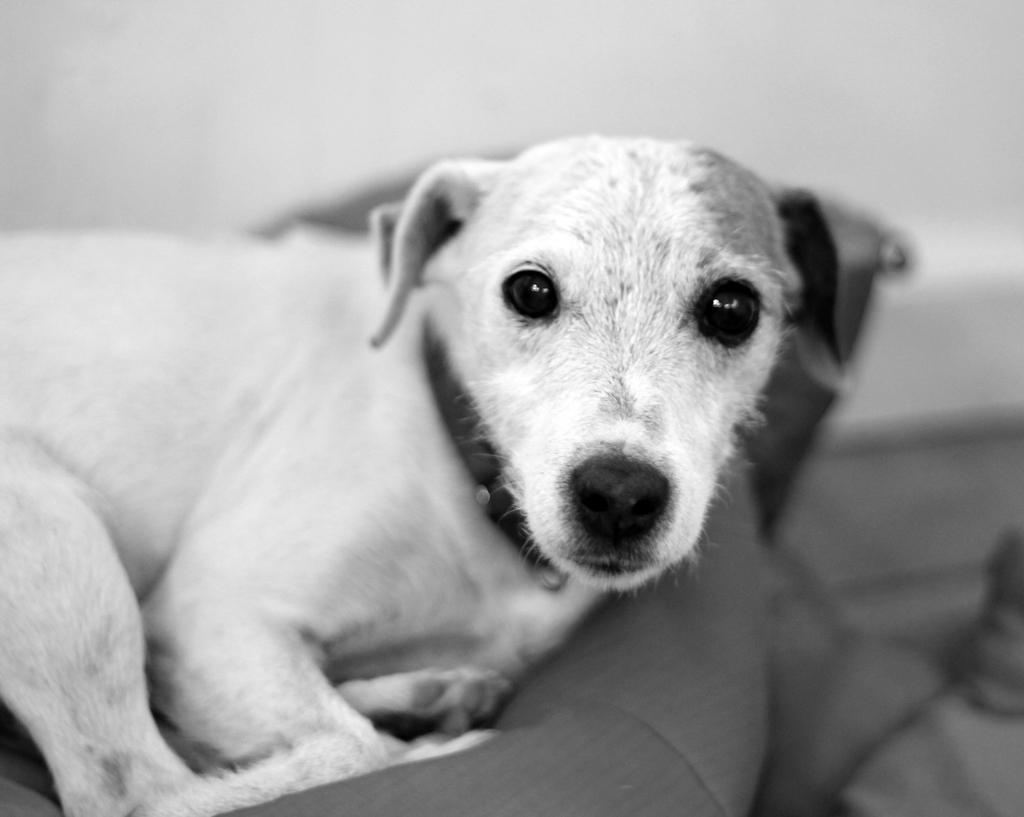What is the color scheme of the image? The image is black and white. What animal can be seen in the image? There is a dog in the image. Can you describe the background of the image? The background appears blurry. What type of orange can be seen in the image? There is no orange present in the image; it is a black and white image featuring a dog. 